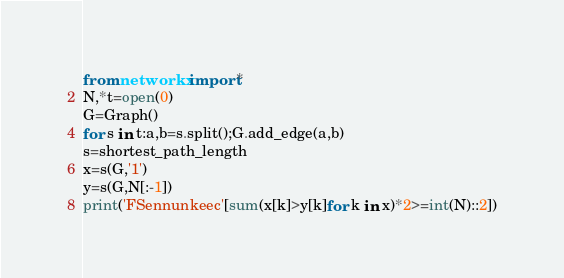<code> <loc_0><loc_0><loc_500><loc_500><_Python_>from networkx import*
N,*t=open(0)
G=Graph()
for s in t:a,b=s.split();G.add_edge(a,b)
s=shortest_path_length
x=s(G,'1')
y=s(G,N[:-1])
print('FSennunkeec'[sum(x[k]>y[k]for k in x)*2>=int(N)::2])</code> 